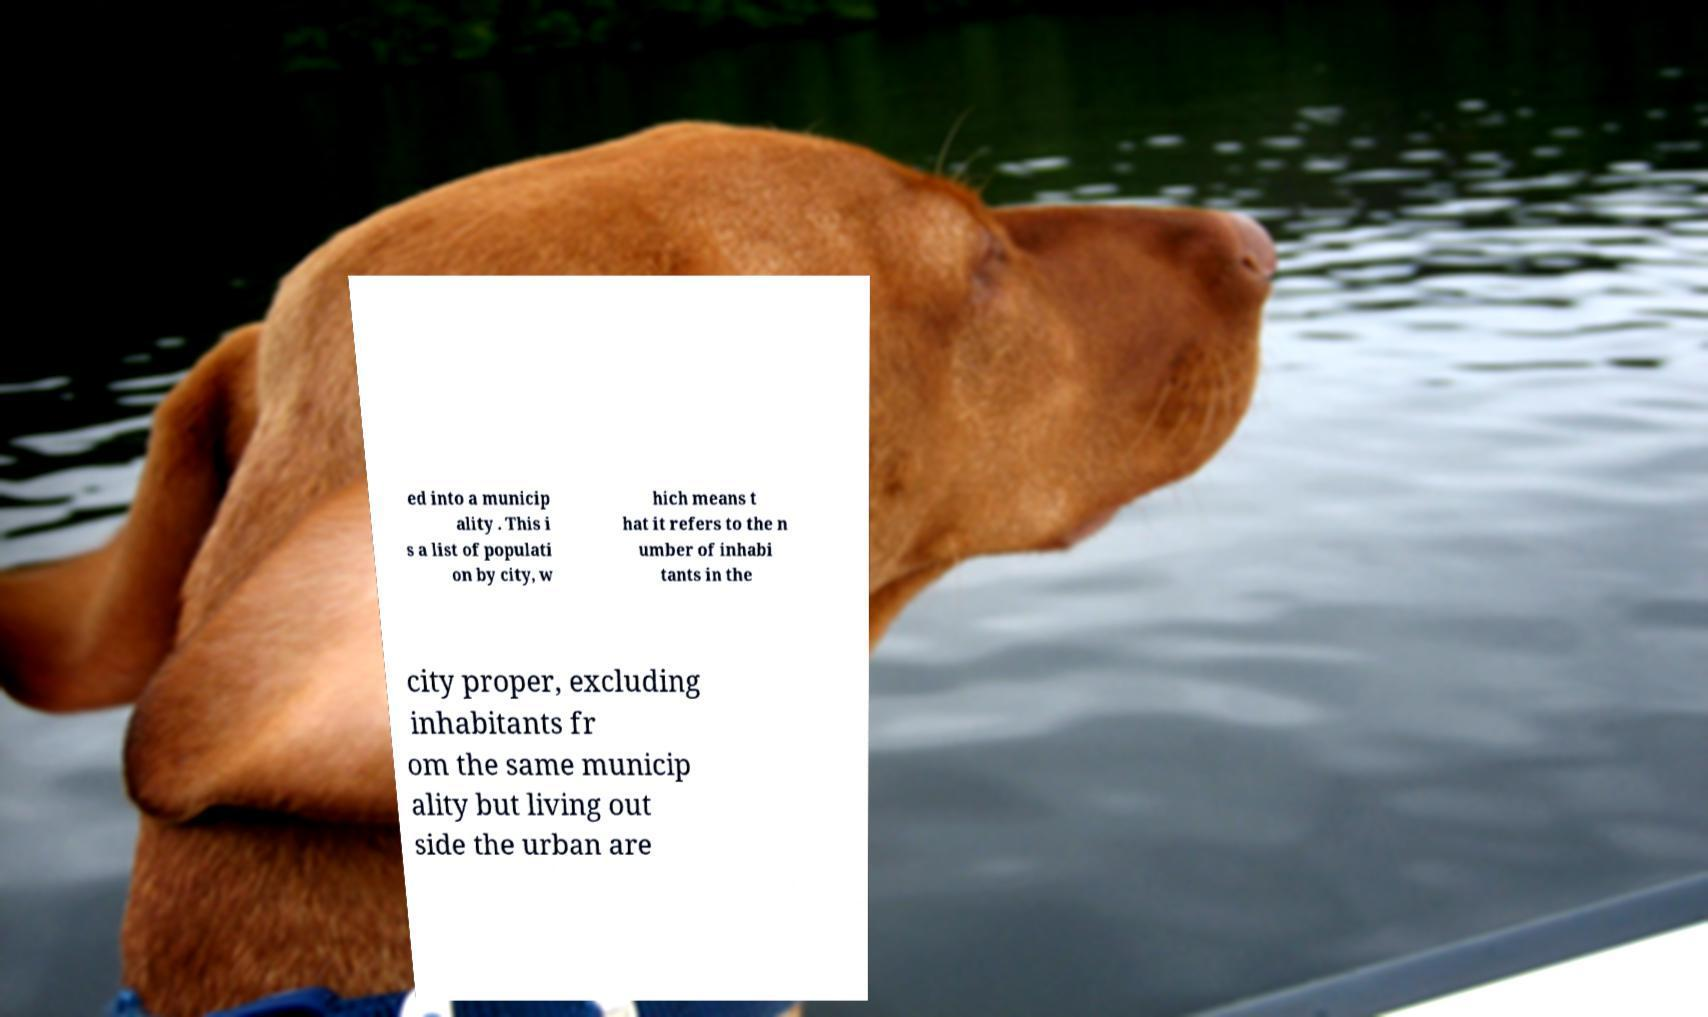Could you assist in decoding the text presented in this image and type it out clearly? ed into a municip ality . This i s a list of populati on by city, w hich means t hat it refers to the n umber of inhabi tants in the city proper, excluding inhabitants fr om the same municip ality but living out side the urban are 